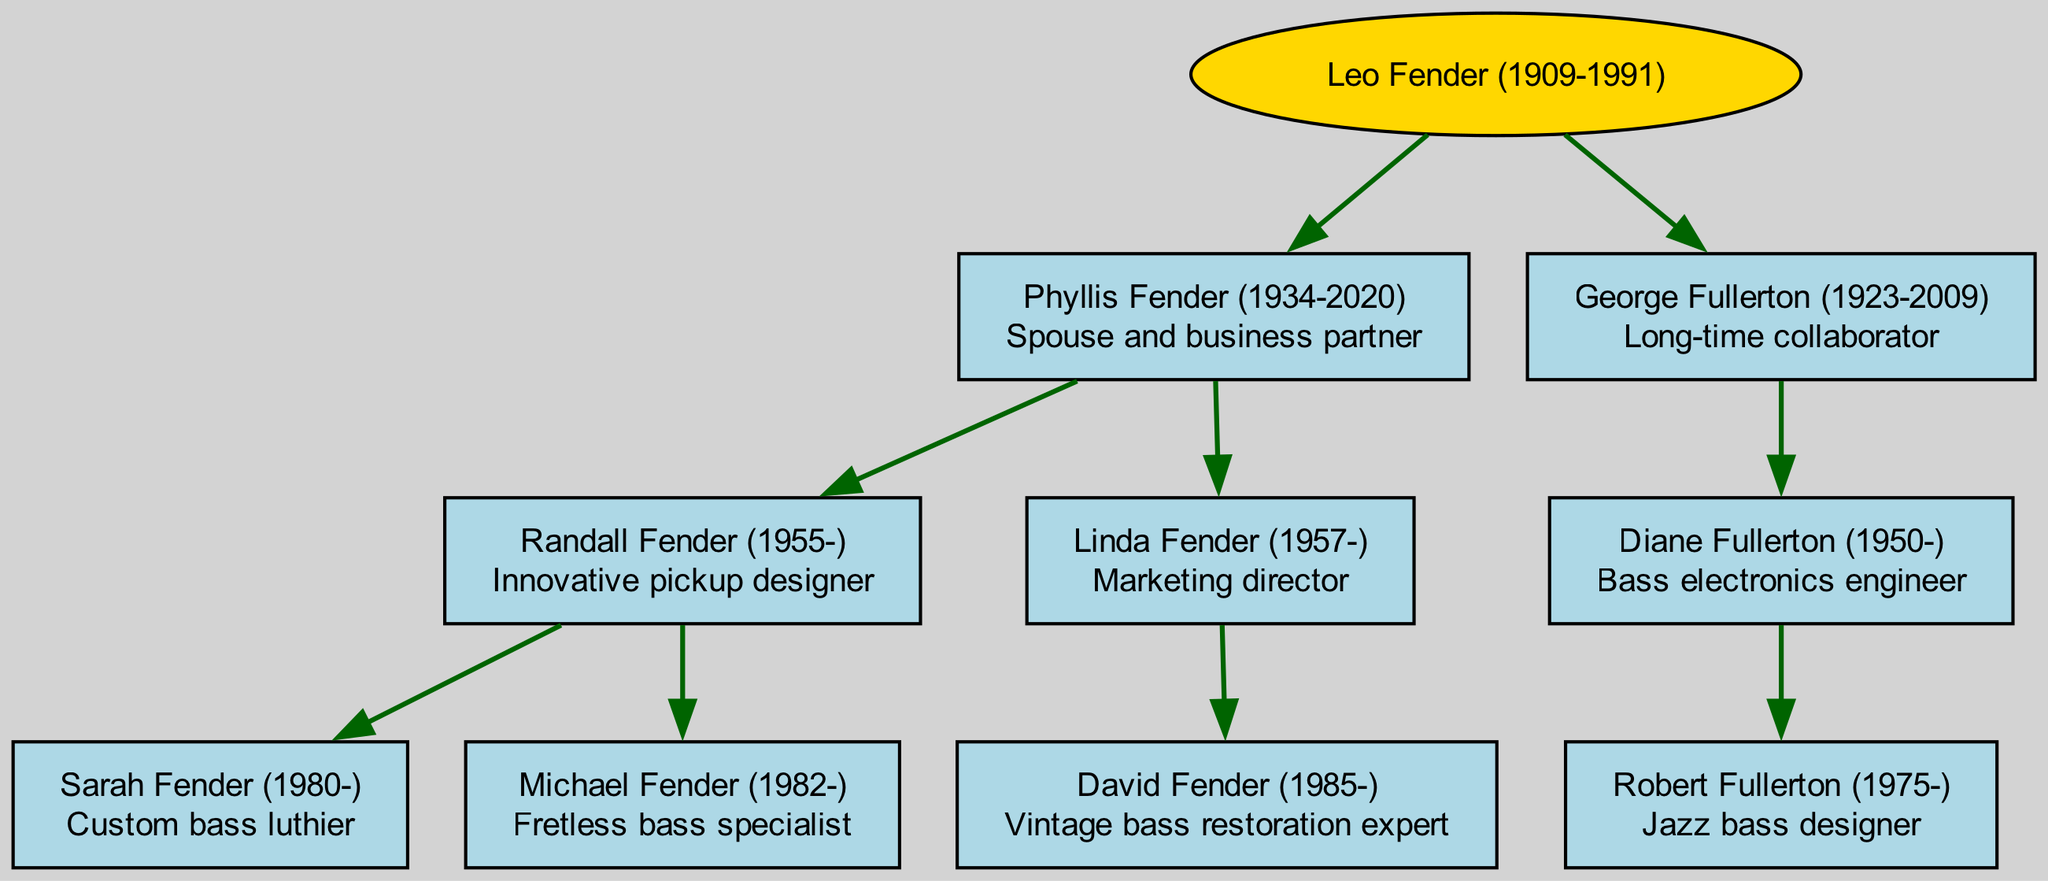What is the name of the founder of the family tree? The root of the diagram represents the founder, who is Leo Fender, as indicated in the top level of the tree.
Answer: Leo Fender Who is the spouse of Leo Fender? The spouse of Leo Fender is shown as a direct child node connected to him; her name is Phyllis Fender.
Answer: Phyllis Fender How many children does Phyllis Fender have? Phyllis Fender has two children listed in the diagram: Randall Fender and Linda Fender. By counting the child nodes under Phyllis, the answer is determined.
Answer: 2 What is the profession of Randall Fender? The diagram indicates Randall Fender's role as an "Innovative pickup designer," which is stated in the label of his node.
Answer: Innovative pickup designer Who is the bass restoration expert in the family? By looking through the descendant nodes, David Fender, who is connected to Linda Fender, is identified as a "Vintage bass restoration expert."
Answer: David Fender How many generations of luthiers are there in this family tree? The diagram shows three generations: Leo Fender (founder), his children (Randall and Linda), and their children (Sarah, Michael, and David). By counting the distinct levels, the answer can be concluded.
Answer: 3 Which child of Leo Fender is a bass electronics engineer? The third generation is examined, and Diane Fullerton is identified under George Fullerton as a "Bass electronics engineer." This shows her direct relation and profession stated in the diagram.
Answer: Diane Fullerton Who designed jazz basses in this family? Robert Fullerton is shown in the tree under Diane Fullerton, and he is labeled as a "Jazz bass designer," making him the correct answer.
Answer: Robert Fullerton What is the role of George Fullerton in this family tree? The diagram clearly states that George Fullerton is a "Long-time collaborator." This is indicated next to his name in the tree structure.
Answer: Long-time collaborator 